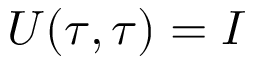<formula> <loc_0><loc_0><loc_500><loc_500>U ( \tau , \tau ) = I</formula> 